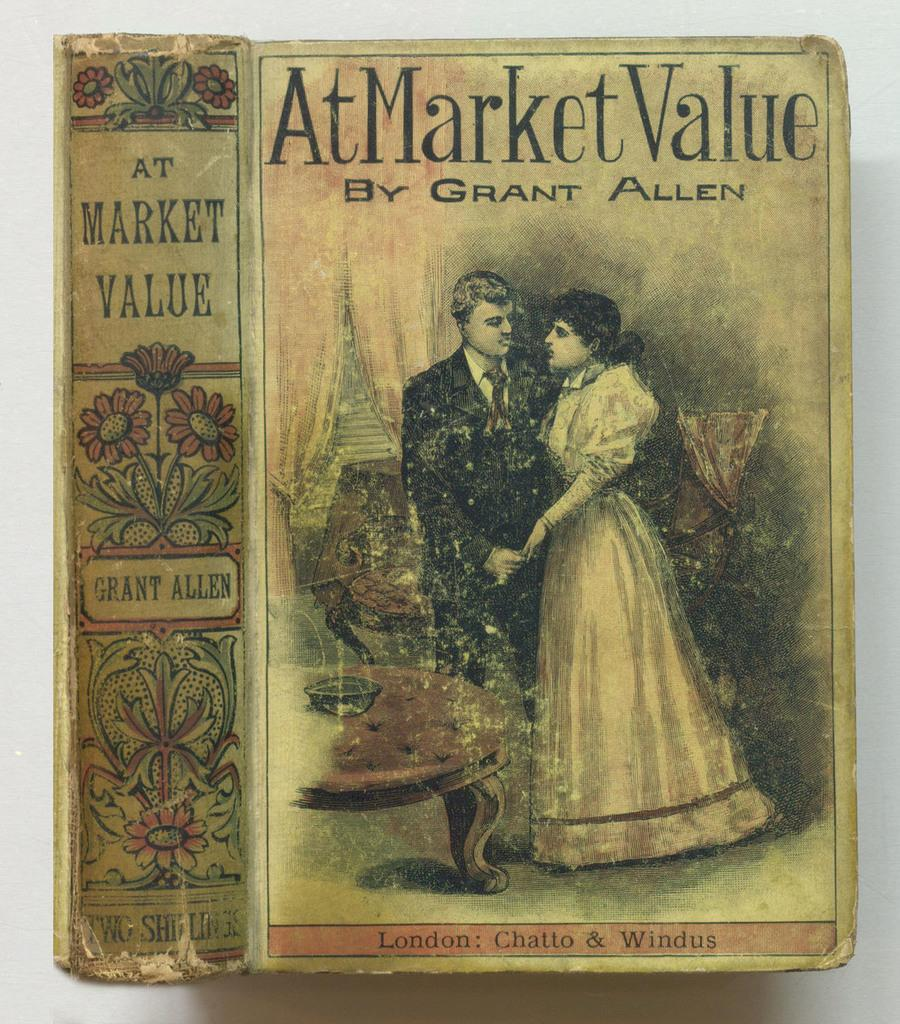<image>
Give a short and clear explanation of the subsequent image. A copy of the book At Market Value by Grant Allen. 